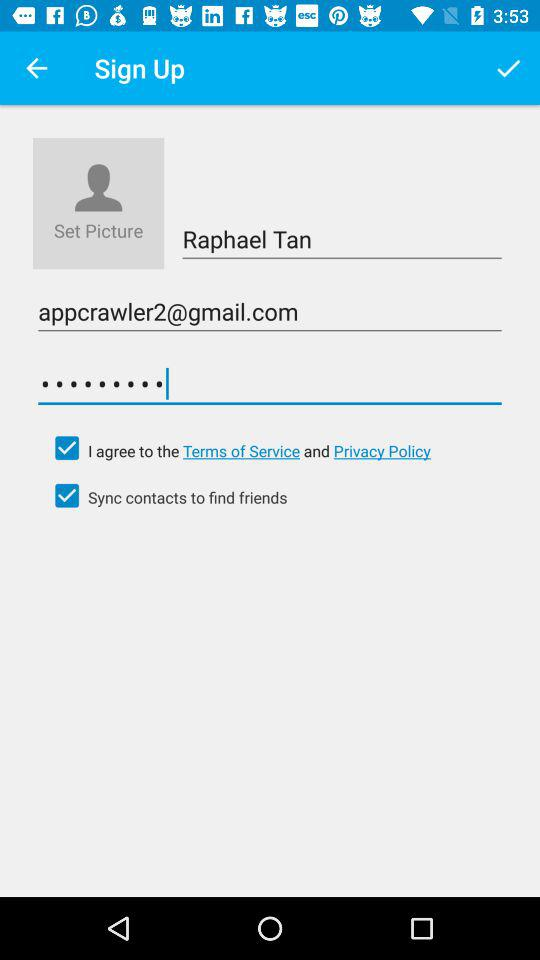What is the email address? The email address is appcrawler2@gmail.com. 